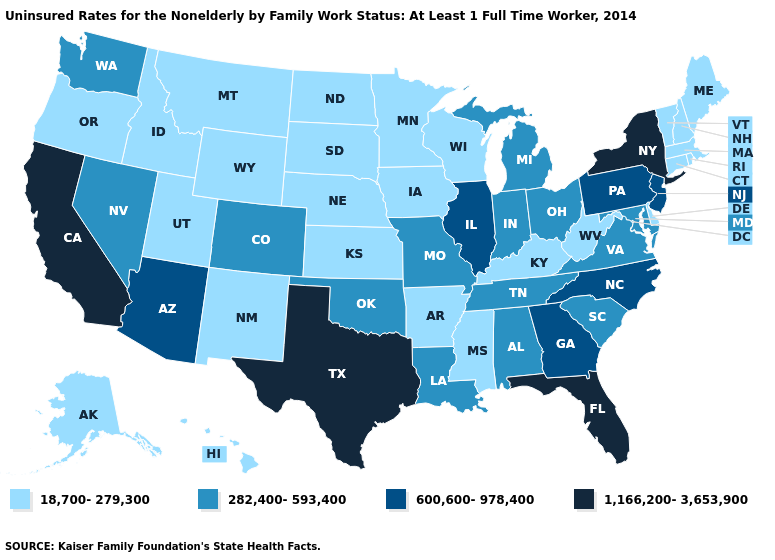What is the highest value in the Northeast ?
Answer briefly. 1,166,200-3,653,900. Which states hav the highest value in the West?
Answer briefly. California. Name the states that have a value in the range 282,400-593,400?
Be succinct. Alabama, Colorado, Indiana, Louisiana, Maryland, Michigan, Missouri, Nevada, Ohio, Oklahoma, South Carolina, Tennessee, Virginia, Washington. Among the states that border Wisconsin , which have the highest value?
Answer briefly. Illinois. Name the states that have a value in the range 282,400-593,400?
Be succinct. Alabama, Colorado, Indiana, Louisiana, Maryland, Michigan, Missouri, Nevada, Ohio, Oklahoma, South Carolina, Tennessee, Virginia, Washington. Name the states that have a value in the range 1,166,200-3,653,900?
Quick response, please. California, Florida, New York, Texas. Which states have the lowest value in the USA?
Keep it brief. Alaska, Arkansas, Connecticut, Delaware, Hawaii, Idaho, Iowa, Kansas, Kentucky, Maine, Massachusetts, Minnesota, Mississippi, Montana, Nebraska, New Hampshire, New Mexico, North Dakota, Oregon, Rhode Island, South Dakota, Utah, Vermont, West Virginia, Wisconsin, Wyoming. What is the lowest value in the West?
Short answer required. 18,700-279,300. What is the value of Louisiana?
Answer briefly. 282,400-593,400. What is the highest value in the USA?
Concise answer only. 1,166,200-3,653,900. Name the states that have a value in the range 282,400-593,400?
Quick response, please. Alabama, Colorado, Indiana, Louisiana, Maryland, Michigan, Missouri, Nevada, Ohio, Oklahoma, South Carolina, Tennessee, Virginia, Washington. Does Alaska have a lower value than West Virginia?
Concise answer only. No. What is the highest value in the West ?
Concise answer only. 1,166,200-3,653,900. Among the states that border Tennessee , which have the highest value?
Give a very brief answer. Georgia, North Carolina. Name the states that have a value in the range 282,400-593,400?
Be succinct. Alabama, Colorado, Indiana, Louisiana, Maryland, Michigan, Missouri, Nevada, Ohio, Oklahoma, South Carolina, Tennessee, Virginia, Washington. 